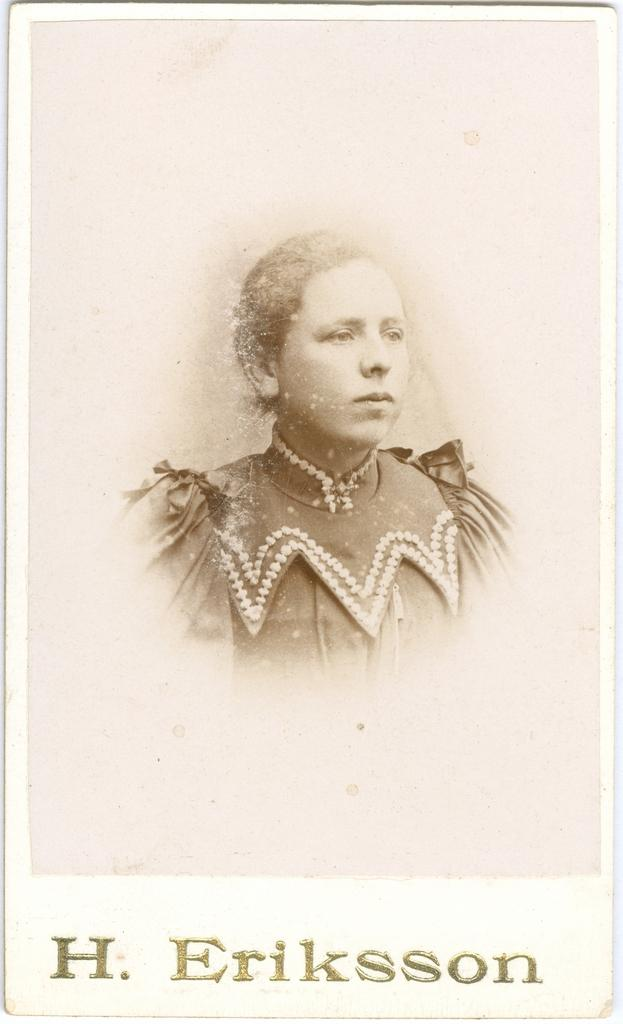What is the main subject of the image? There is a photo of a woman in the image. Can you describe any additional elements in the image? Yes, there is text in the image. Where is the woman cooking in the image? The image does not show the woman cooking; it only shows a photo of her. What type of alley can be seen in the image? There is no alley present in the image. 